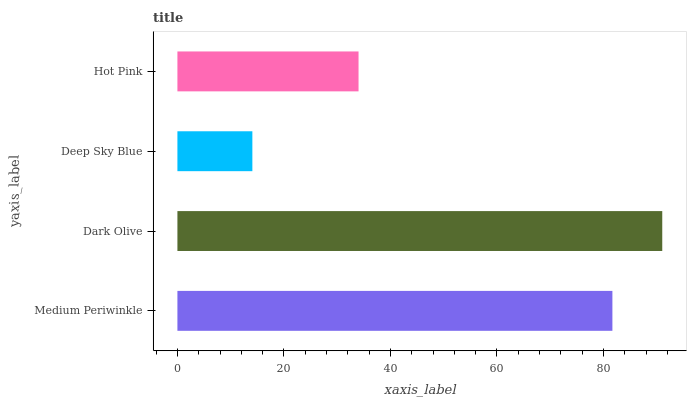Is Deep Sky Blue the minimum?
Answer yes or no. Yes. Is Dark Olive the maximum?
Answer yes or no. Yes. Is Dark Olive the minimum?
Answer yes or no. No. Is Deep Sky Blue the maximum?
Answer yes or no. No. Is Dark Olive greater than Deep Sky Blue?
Answer yes or no. Yes. Is Deep Sky Blue less than Dark Olive?
Answer yes or no. Yes. Is Deep Sky Blue greater than Dark Olive?
Answer yes or no. No. Is Dark Olive less than Deep Sky Blue?
Answer yes or no. No. Is Medium Periwinkle the high median?
Answer yes or no. Yes. Is Hot Pink the low median?
Answer yes or no. Yes. Is Deep Sky Blue the high median?
Answer yes or no. No. Is Dark Olive the low median?
Answer yes or no. No. 